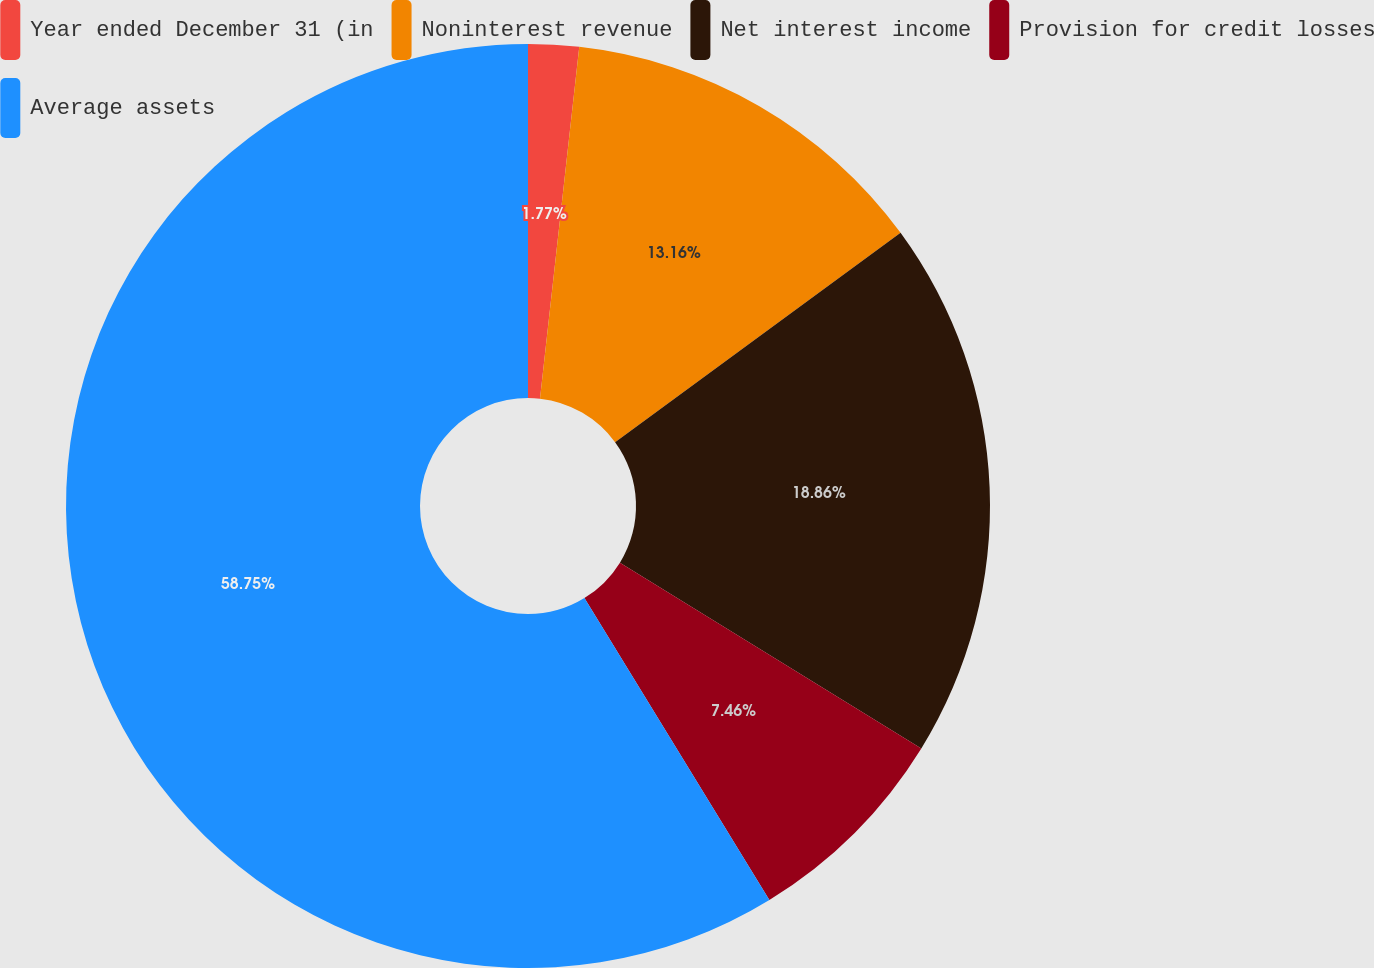<chart> <loc_0><loc_0><loc_500><loc_500><pie_chart><fcel>Year ended December 31 (in<fcel>Noninterest revenue<fcel>Net interest income<fcel>Provision for credit losses<fcel>Average assets<nl><fcel>1.77%<fcel>13.16%<fcel>18.86%<fcel>7.46%<fcel>58.75%<nl></chart> 